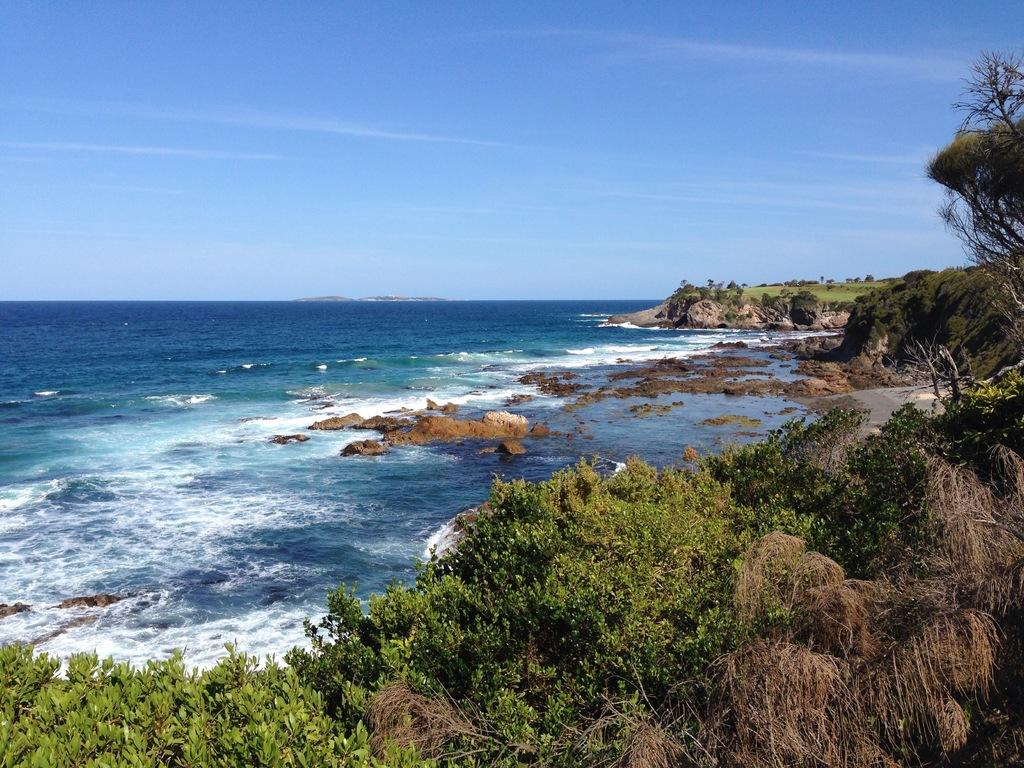What is the primary element visible in the image? There is water in the image. What can be found within the water? There are rocks in the water. What type of vegetation is present at the bottom of the image? There are trees at the bottom of the image. What is the landscape like on the right side of the image? There is a grassland on the right side of the image. What can be found within the grassland? There are rocks and trees in the grassland. What is visible at the top of the image? The sky is visible at the top of the image. Can you tell me how many wheels are visible in the image? There are no wheels present in the image. What type of monkey can be seen climbing the trees in the grassland? There are no monkeys present in the image; it only features trees and rocks in the grassland. 